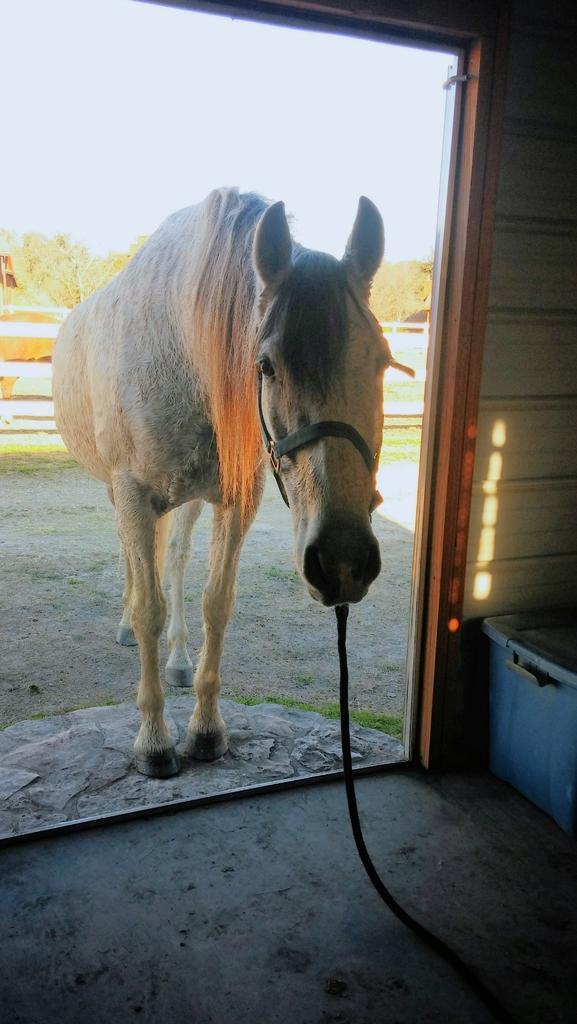Could you give a brief overview of what you see in this image? In the image there is a horse tied to a rope standing outside of an entrance and in the background there are trees and above its sky. 